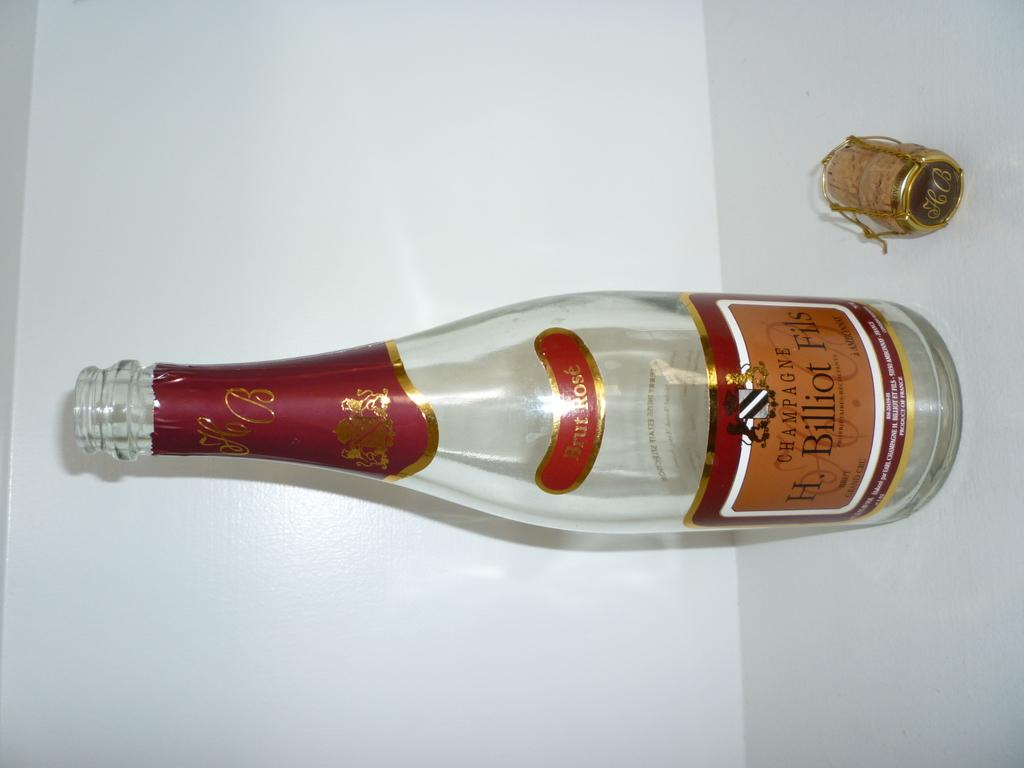<image>
Give a short and clear explanation of the subsequent image. H Billiot Fils bottle of Champagne on a white table 